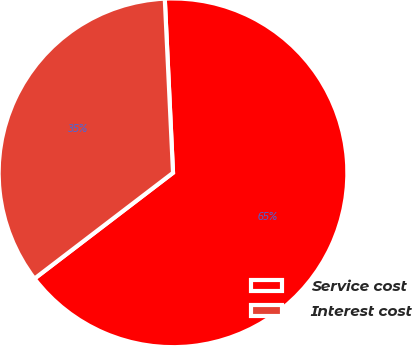Convert chart to OTSL. <chart><loc_0><loc_0><loc_500><loc_500><pie_chart><fcel>Service cost<fcel>Interest cost<nl><fcel>65.37%<fcel>34.63%<nl></chart> 